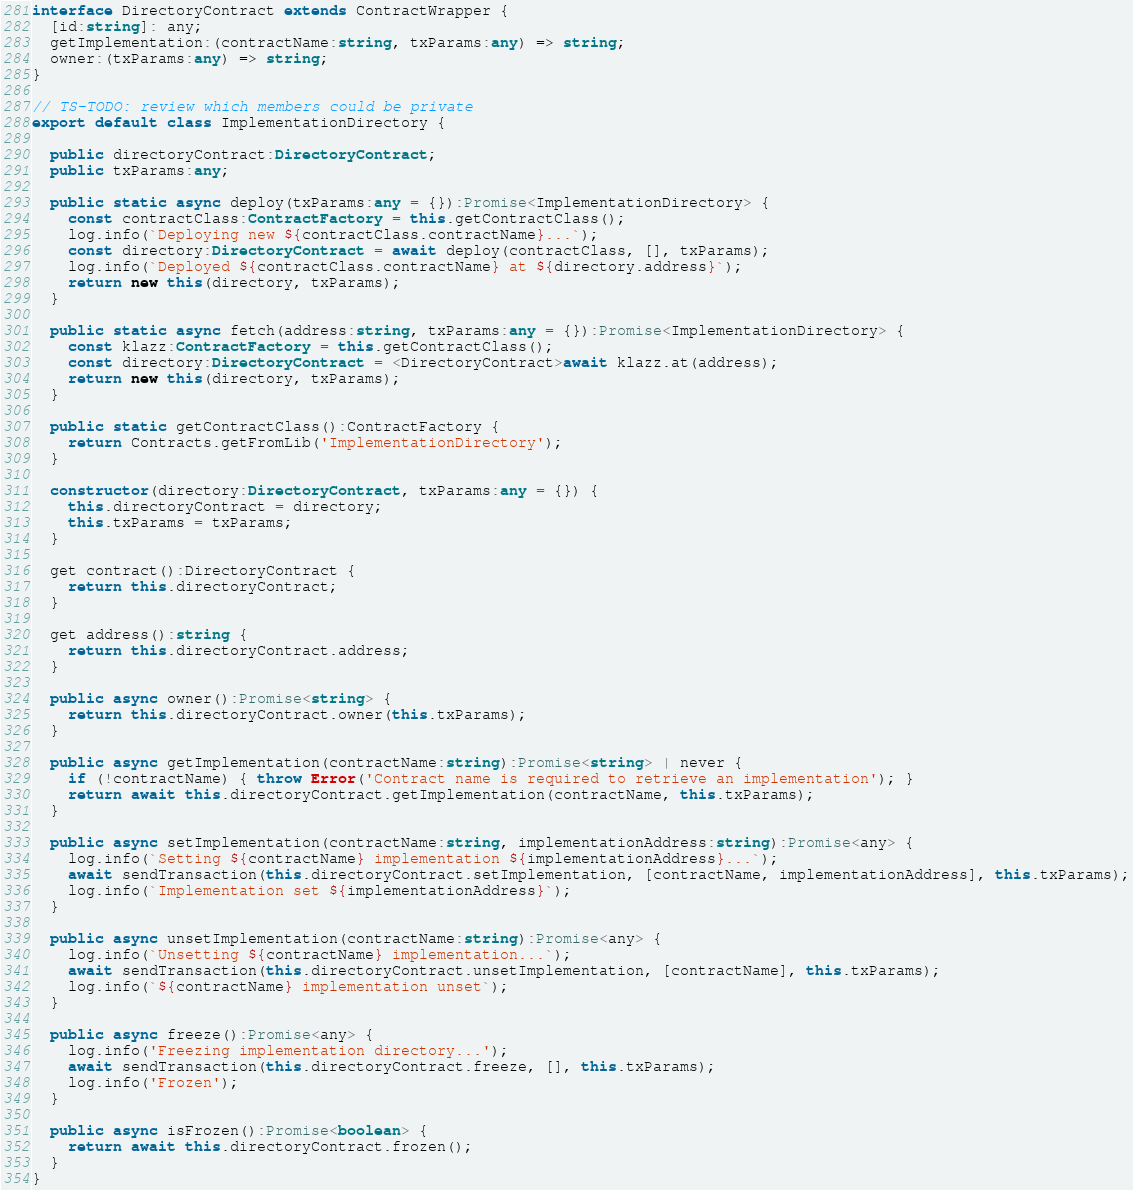Convert code to text. <code><loc_0><loc_0><loc_500><loc_500><_TypeScript_>interface DirectoryContract extends ContractWrapper {
  [id:string]: any;
  getImplementation:(contractName:string, txParams:any) => string;
  owner:(txParams:any) => string;
}

// TS-TODO: review which members could be private
export default class ImplementationDirectory {

  public directoryContract:DirectoryContract;
  public txParams:any;

  public static async deploy(txParams:any = {}):Promise<ImplementationDirectory> {
    const contractClass:ContractFactory = this.getContractClass();
    log.info(`Deploying new ${contractClass.contractName}...`);
    const directory:DirectoryContract = await deploy(contractClass, [], txParams);
    log.info(`Deployed ${contractClass.contractName} at ${directory.address}`);
    return new this(directory, txParams);
  }

  public static async fetch(address:string, txParams:any = {}):Promise<ImplementationDirectory> {
    const klazz:ContractFactory = this.getContractClass();
    const directory:DirectoryContract = <DirectoryContract>await klazz.at(address);
    return new this(directory, txParams);
  }

  public static getContractClass():ContractFactory {
    return Contracts.getFromLib('ImplementationDirectory');
  }

  constructor(directory:DirectoryContract, txParams:any = {}) {
    this.directoryContract = directory;
    this.txParams = txParams;
  }

  get contract():DirectoryContract {
    return this.directoryContract;
  }

  get address():string {
    return this.directoryContract.address;
  }

  public async owner():Promise<string> {
    return this.directoryContract.owner(this.txParams);
  }

  public async getImplementation(contractName:string):Promise<string> | never {
    if (!contractName) { throw Error('Contract name is required to retrieve an implementation'); }
    return await this.directoryContract.getImplementation(contractName, this.txParams);
  }

  public async setImplementation(contractName:string, implementationAddress:string):Promise<any> {
    log.info(`Setting ${contractName} implementation ${implementationAddress}...`);
    await sendTransaction(this.directoryContract.setImplementation, [contractName, implementationAddress], this.txParams);
    log.info(`Implementation set ${implementationAddress}`);
  }

  public async unsetImplementation(contractName:string):Promise<any> {
    log.info(`Unsetting ${contractName} implementation...`);
    await sendTransaction(this.directoryContract.unsetImplementation, [contractName], this.txParams);
    log.info(`${contractName} implementation unset`);
  }

  public async freeze():Promise<any> {
    log.info('Freezing implementation directory...');
    await sendTransaction(this.directoryContract.freeze, [], this.txParams);
    log.info('Frozen');
  }

  public async isFrozen():Promise<boolean> {
    return await this.directoryContract.frozen();
  }
}
</code> 